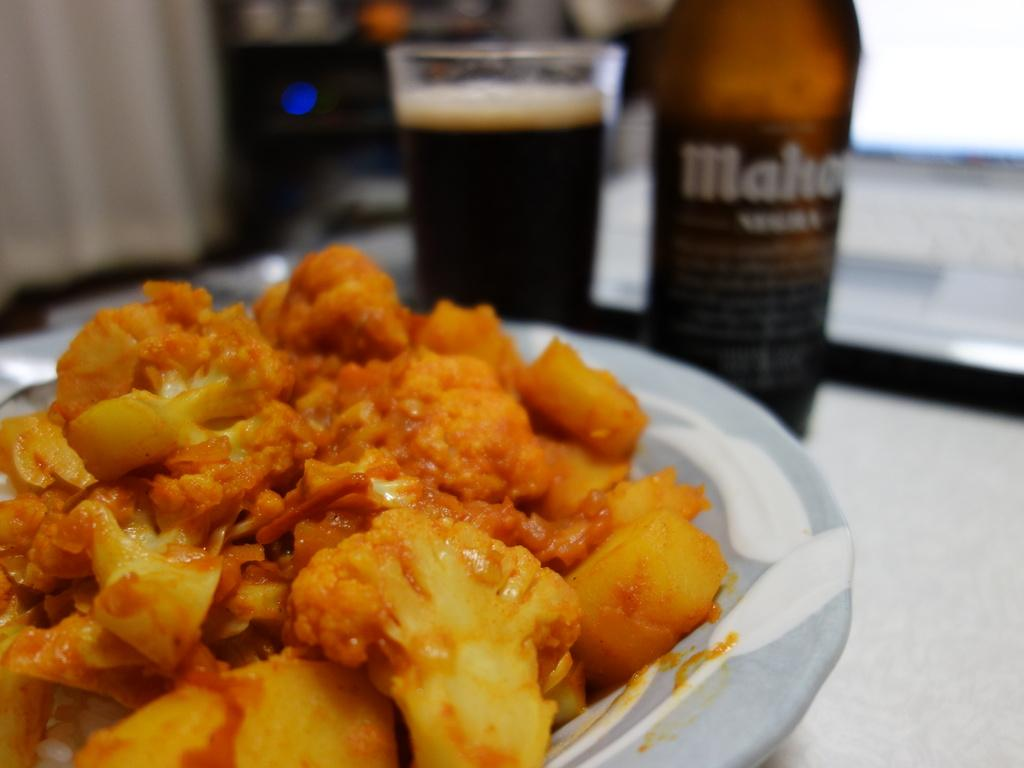What is on the plate in the image? There is food in a plate in the image. What other objects can be seen in the image? There is a bottle and a glass with a drink in the image. Where are these objects placed? The objects are placed on a platform. Can you describe the background of the image? The background of the image is blurred. What type of polish is being applied to the crate in the image? There is no crate or polish present in the image. What time is indicated by the clock in the image? There is no clock present in the image. 